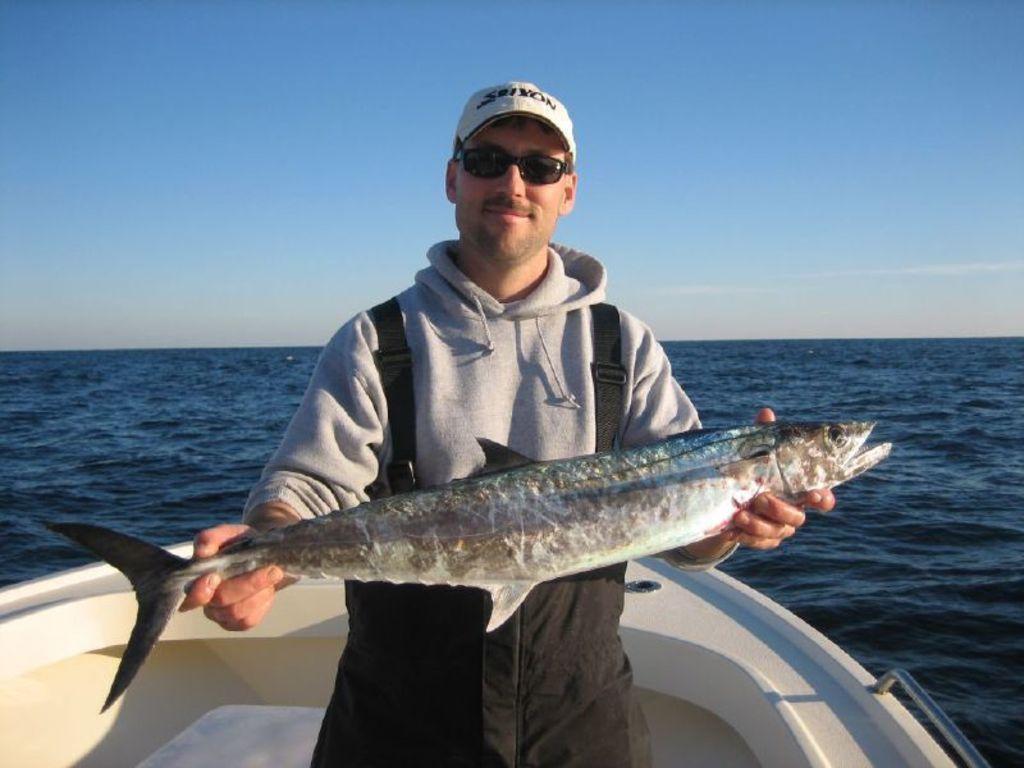Could you give a brief overview of what you see in this image? In this image we can see a person sailing in a watercraft and holding a fish. A person is wearing a cap and a spectacle. There is a sea in the image. We can see the sky in the image. 